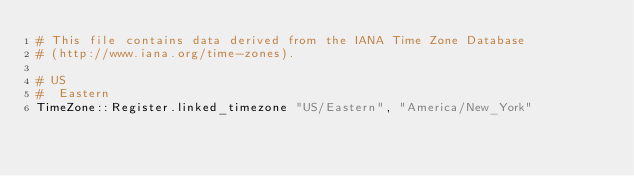Convert code to text. <code><loc_0><loc_0><loc_500><loc_500><_Crystal_># This file contains data derived from the IANA Time Zone Database
# (http://www.iana.org/time-zones).

# US
#  Eastern
TimeZone::Register.linked_timezone "US/Eastern", "America/New_York"
</code> 